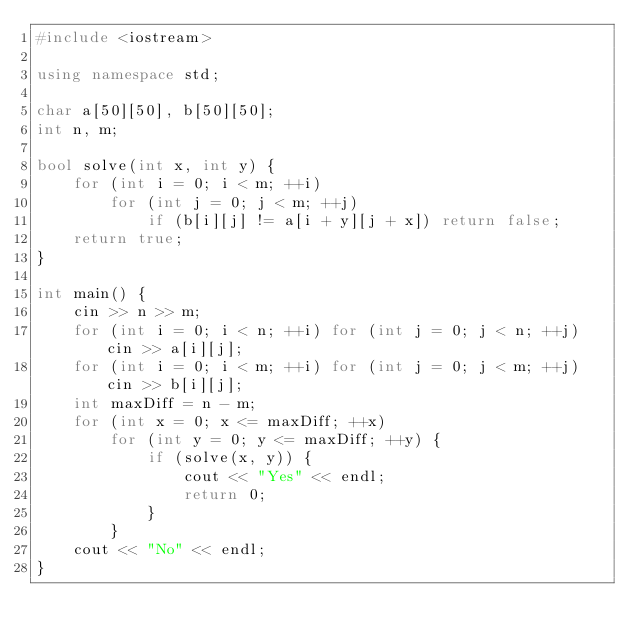Convert code to text. <code><loc_0><loc_0><loc_500><loc_500><_C++_>#include <iostream>

using namespace std;

char a[50][50], b[50][50];
int n, m;

bool solve(int x, int y) {
    for (int i = 0; i < m; ++i)
        for (int j = 0; j < m; ++j)
            if (b[i][j] != a[i + y][j + x]) return false;
    return true;
}

int main() {
    cin >> n >> m;
    for (int i = 0; i < n; ++i) for (int j = 0; j < n; ++j) cin >> a[i][j];
    for (int i = 0; i < m; ++i) for (int j = 0; j < m; ++j) cin >> b[i][j];
    int maxDiff = n - m;
    for (int x = 0; x <= maxDiff; ++x)
        for (int y = 0; y <= maxDiff; ++y) {
            if (solve(x, y)) {
                cout << "Yes" << endl;
                return 0;
            }
        }
    cout << "No" << endl;
}
</code> 